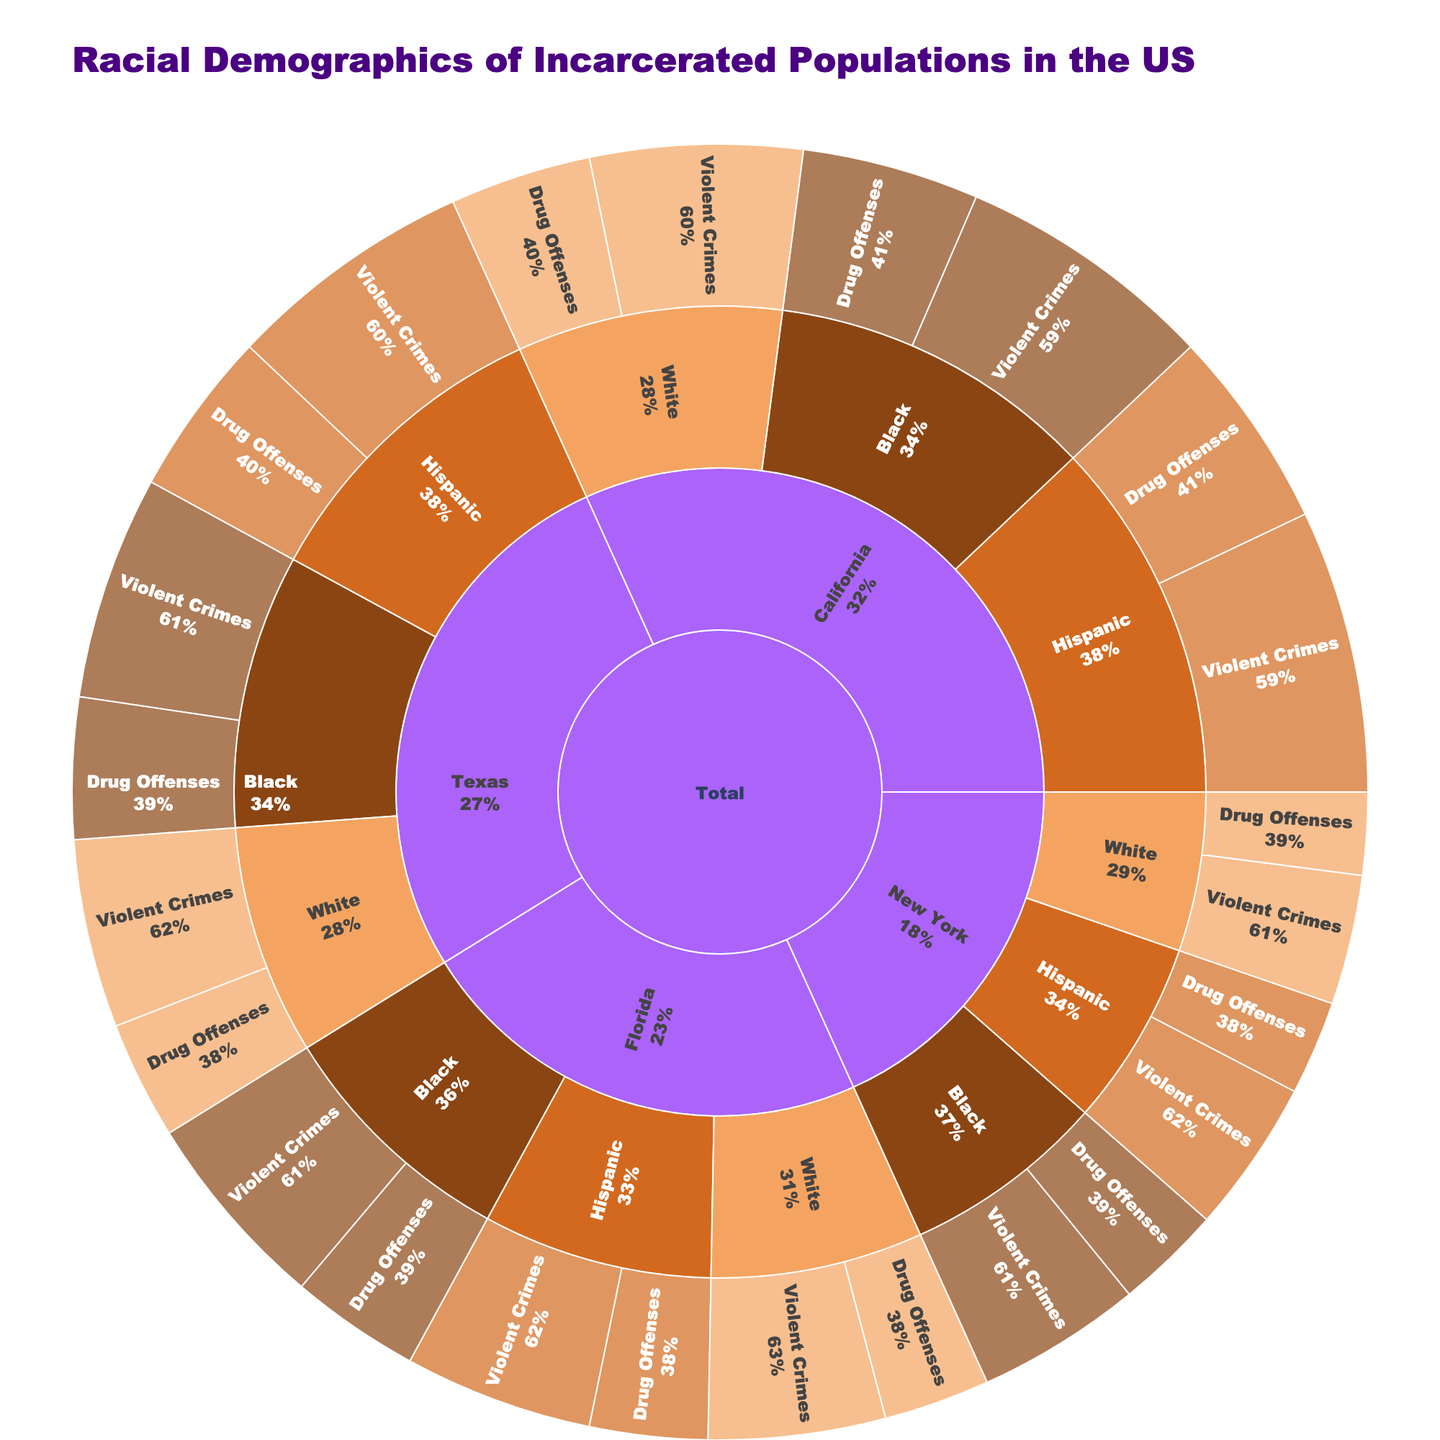How does the population of white individuals incarcerated for drug offenses in Florida compare to those in California? Locate the population of white individuals incarcerated for drug offenses in both Florida and California, and then compare these numbers.
Answer: Florida: 9000, California: 12000 What percentage of the incarcerated population in California is comprised of Black individuals? Identify the total population in California by summing all groups. Calculate the sum of Black individuals in California (drug offenses and violent crimes) and divide it by the total population in California. (15000 + 22000) / (15000 + 22000 + 12000 + 18000 + 17000 + 24000)
Answer: 27.3% Which state has the highest population of Black individuals incarcerated for drug offenses? Compare the population of Black individuals incarcerated for drug offenses across California, Texas, New York, and Florida.
Answer: California What is the combined population of incarcerated Hispanic and White individuals for violent crimes across all states? Sum the populations of Hispanic and White individuals incarcerated for violent crimes in all states. For Hispanic: (California: 24000 + Texas: 21000 + New York: 13000 + Florida: 16000). For White: (California: 18000 + Texas: 16000 + New York: 11000 + Florida 15000). Add these sums together.
Answer: 134000 Which group has a higher average population for violent crimes in New York: Black, White, or Hispanic? Compare the violent crime population values for Black, White, and Hispanic individuals in New York individually (Black: 14000, White: 11000, Hispanic: 13000), and then determine the highest average.
Answer: Black 